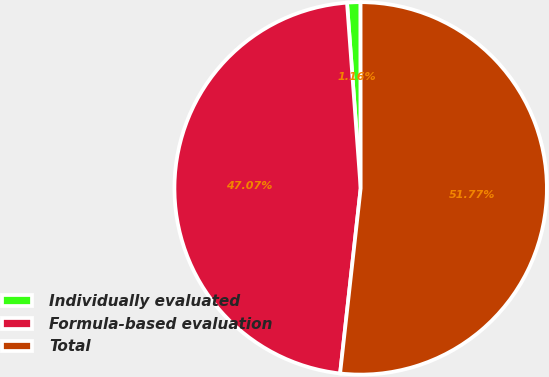Convert chart to OTSL. <chart><loc_0><loc_0><loc_500><loc_500><pie_chart><fcel>Individually evaluated<fcel>Formula-based evaluation<fcel>Total<nl><fcel>1.16%<fcel>47.07%<fcel>51.77%<nl></chart> 